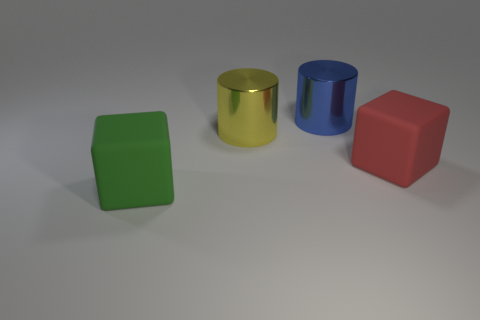Add 3 big blue metal objects. How many objects exist? 7 Subtract 0 gray cylinders. How many objects are left? 4 Subtract all big green matte blocks. Subtract all cyan metallic balls. How many objects are left? 3 Add 1 yellow shiny objects. How many yellow shiny objects are left? 2 Add 2 green cubes. How many green cubes exist? 3 